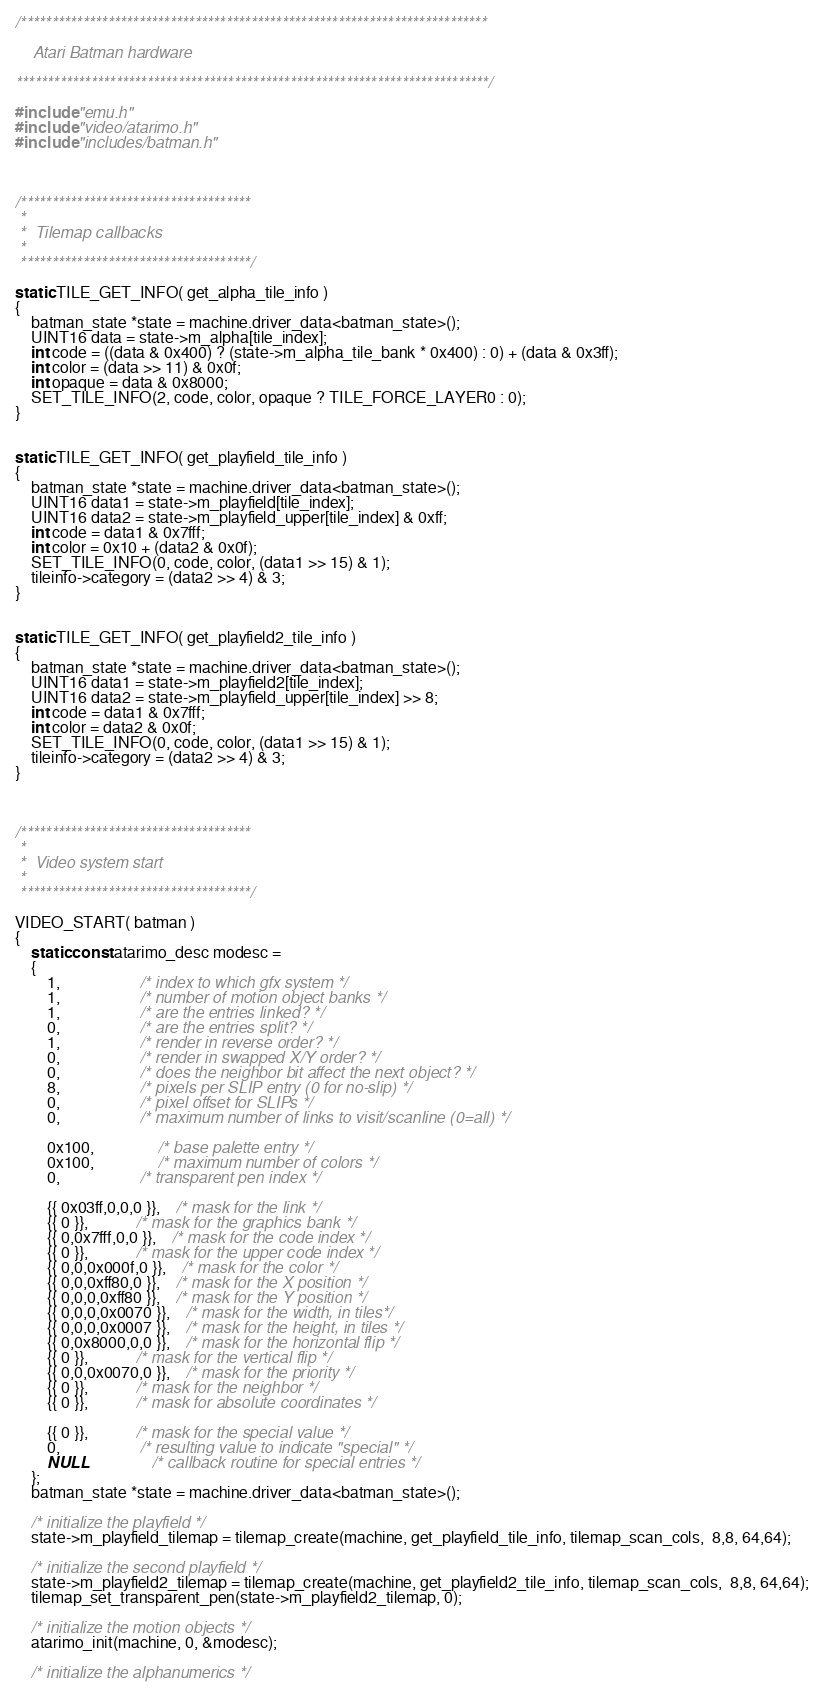<code> <loc_0><loc_0><loc_500><loc_500><_C_>/***************************************************************************

    Atari Batman hardware

****************************************************************************/

#include "emu.h"
#include "video/atarimo.h"
#include "includes/batman.h"



/*************************************
 *
 *  Tilemap callbacks
 *
 *************************************/

static TILE_GET_INFO( get_alpha_tile_info )
{
	batman_state *state = machine.driver_data<batman_state>();
	UINT16 data = state->m_alpha[tile_index];
	int code = ((data & 0x400) ? (state->m_alpha_tile_bank * 0x400) : 0) + (data & 0x3ff);
	int color = (data >> 11) & 0x0f;
	int opaque = data & 0x8000;
	SET_TILE_INFO(2, code, color, opaque ? TILE_FORCE_LAYER0 : 0);
}


static TILE_GET_INFO( get_playfield_tile_info )
{
	batman_state *state = machine.driver_data<batman_state>();
	UINT16 data1 = state->m_playfield[tile_index];
	UINT16 data2 = state->m_playfield_upper[tile_index] & 0xff;
	int code = data1 & 0x7fff;
	int color = 0x10 + (data2 & 0x0f);
	SET_TILE_INFO(0, code, color, (data1 >> 15) & 1);
	tileinfo->category = (data2 >> 4) & 3;
}


static TILE_GET_INFO( get_playfield2_tile_info )
{
	batman_state *state = machine.driver_data<batman_state>();
	UINT16 data1 = state->m_playfield2[tile_index];
	UINT16 data2 = state->m_playfield_upper[tile_index] >> 8;
	int code = data1 & 0x7fff;
	int color = data2 & 0x0f;
	SET_TILE_INFO(0, code, color, (data1 >> 15) & 1);
	tileinfo->category = (data2 >> 4) & 3;
}



/*************************************
 *
 *  Video system start
 *
 *************************************/

VIDEO_START( batman )
{
	static const atarimo_desc modesc =
	{
		1,					/* index to which gfx system */
		1,					/* number of motion object banks */
		1,					/* are the entries linked? */
		0,					/* are the entries split? */
		1,					/* render in reverse order? */
		0,					/* render in swapped X/Y order? */
		0,					/* does the neighbor bit affect the next object? */
		8,					/* pixels per SLIP entry (0 for no-slip) */
		0,					/* pixel offset for SLIPs */
		0,					/* maximum number of links to visit/scanline (0=all) */

		0x100,				/* base palette entry */
		0x100,				/* maximum number of colors */
		0,					/* transparent pen index */

		{{ 0x03ff,0,0,0 }},	/* mask for the link */
		{{ 0 }},			/* mask for the graphics bank */
		{{ 0,0x7fff,0,0 }},	/* mask for the code index */
		{{ 0 }},			/* mask for the upper code index */
		{{ 0,0,0x000f,0 }},	/* mask for the color */
		{{ 0,0,0xff80,0 }},	/* mask for the X position */
		{{ 0,0,0,0xff80 }},	/* mask for the Y position */
		{{ 0,0,0,0x0070 }},	/* mask for the width, in tiles*/
		{{ 0,0,0,0x0007 }},	/* mask for the height, in tiles */
		{{ 0,0x8000,0,0 }},	/* mask for the horizontal flip */
		{{ 0 }},			/* mask for the vertical flip */
		{{ 0,0,0x0070,0 }},	/* mask for the priority */
		{{ 0 }},			/* mask for the neighbor */
		{{ 0 }},			/* mask for absolute coordinates */

		{{ 0 }},			/* mask for the special value */
		0,					/* resulting value to indicate "special" */
		NULL				/* callback routine for special entries */
	};
	batman_state *state = machine.driver_data<batman_state>();

	/* initialize the playfield */
	state->m_playfield_tilemap = tilemap_create(machine, get_playfield_tile_info, tilemap_scan_cols,  8,8, 64,64);

	/* initialize the second playfield */
	state->m_playfield2_tilemap = tilemap_create(machine, get_playfield2_tile_info, tilemap_scan_cols,  8,8, 64,64);
	tilemap_set_transparent_pen(state->m_playfield2_tilemap, 0);

	/* initialize the motion objects */
	atarimo_init(machine, 0, &modesc);

	/* initialize the alphanumerics */</code> 